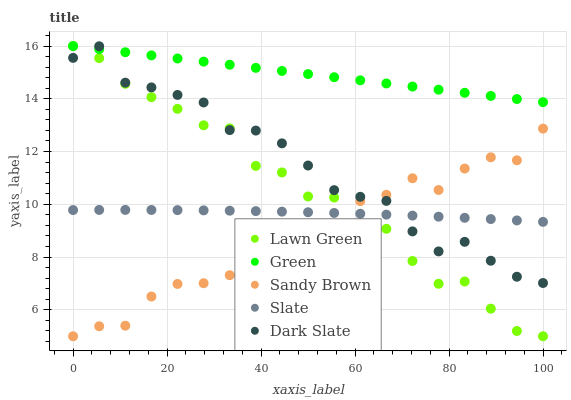Does Sandy Brown have the minimum area under the curve?
Answer yes or no. Yes. Does Green have the maximum area under the curve?
Answer yes or no. Yes. Does Slate have the minimum area under the curve?
Answer yes or no. No. Does Slate have the maximum area under the curve?
Answer yes or no. No. Is Green the smoothest?
Answer yes or no. Yes. Is Lawn Green the roughest?
Answer yes or no. Yes. Is Slate the smoothest?
Answer yes or no. No. Is Slate the roughest?
Answer yes or no. No. Does Lawn Green have the lowest value?
Answer yes or no. Yes. Does Slate have the lowest value?
Answer yes or no. No. Does Green have the highest value?
Answer yes or no. Yes. Does Slate have the highest value?
Answer yes or no. No. Is Slate less than Green?
Answer yes or no. Yes. Is Green greater than Sandy Brown?
Answer yes or no. Yes. Does Lawn Green intersect Green?
Answer yes or no. Yes. Is Lawn Green less than Green?
Answer yes or no. No. Is Lawn Green greater than Green?
Answer yes or no. No. Does Slate intersect Green?
Answer yes or no. No. 